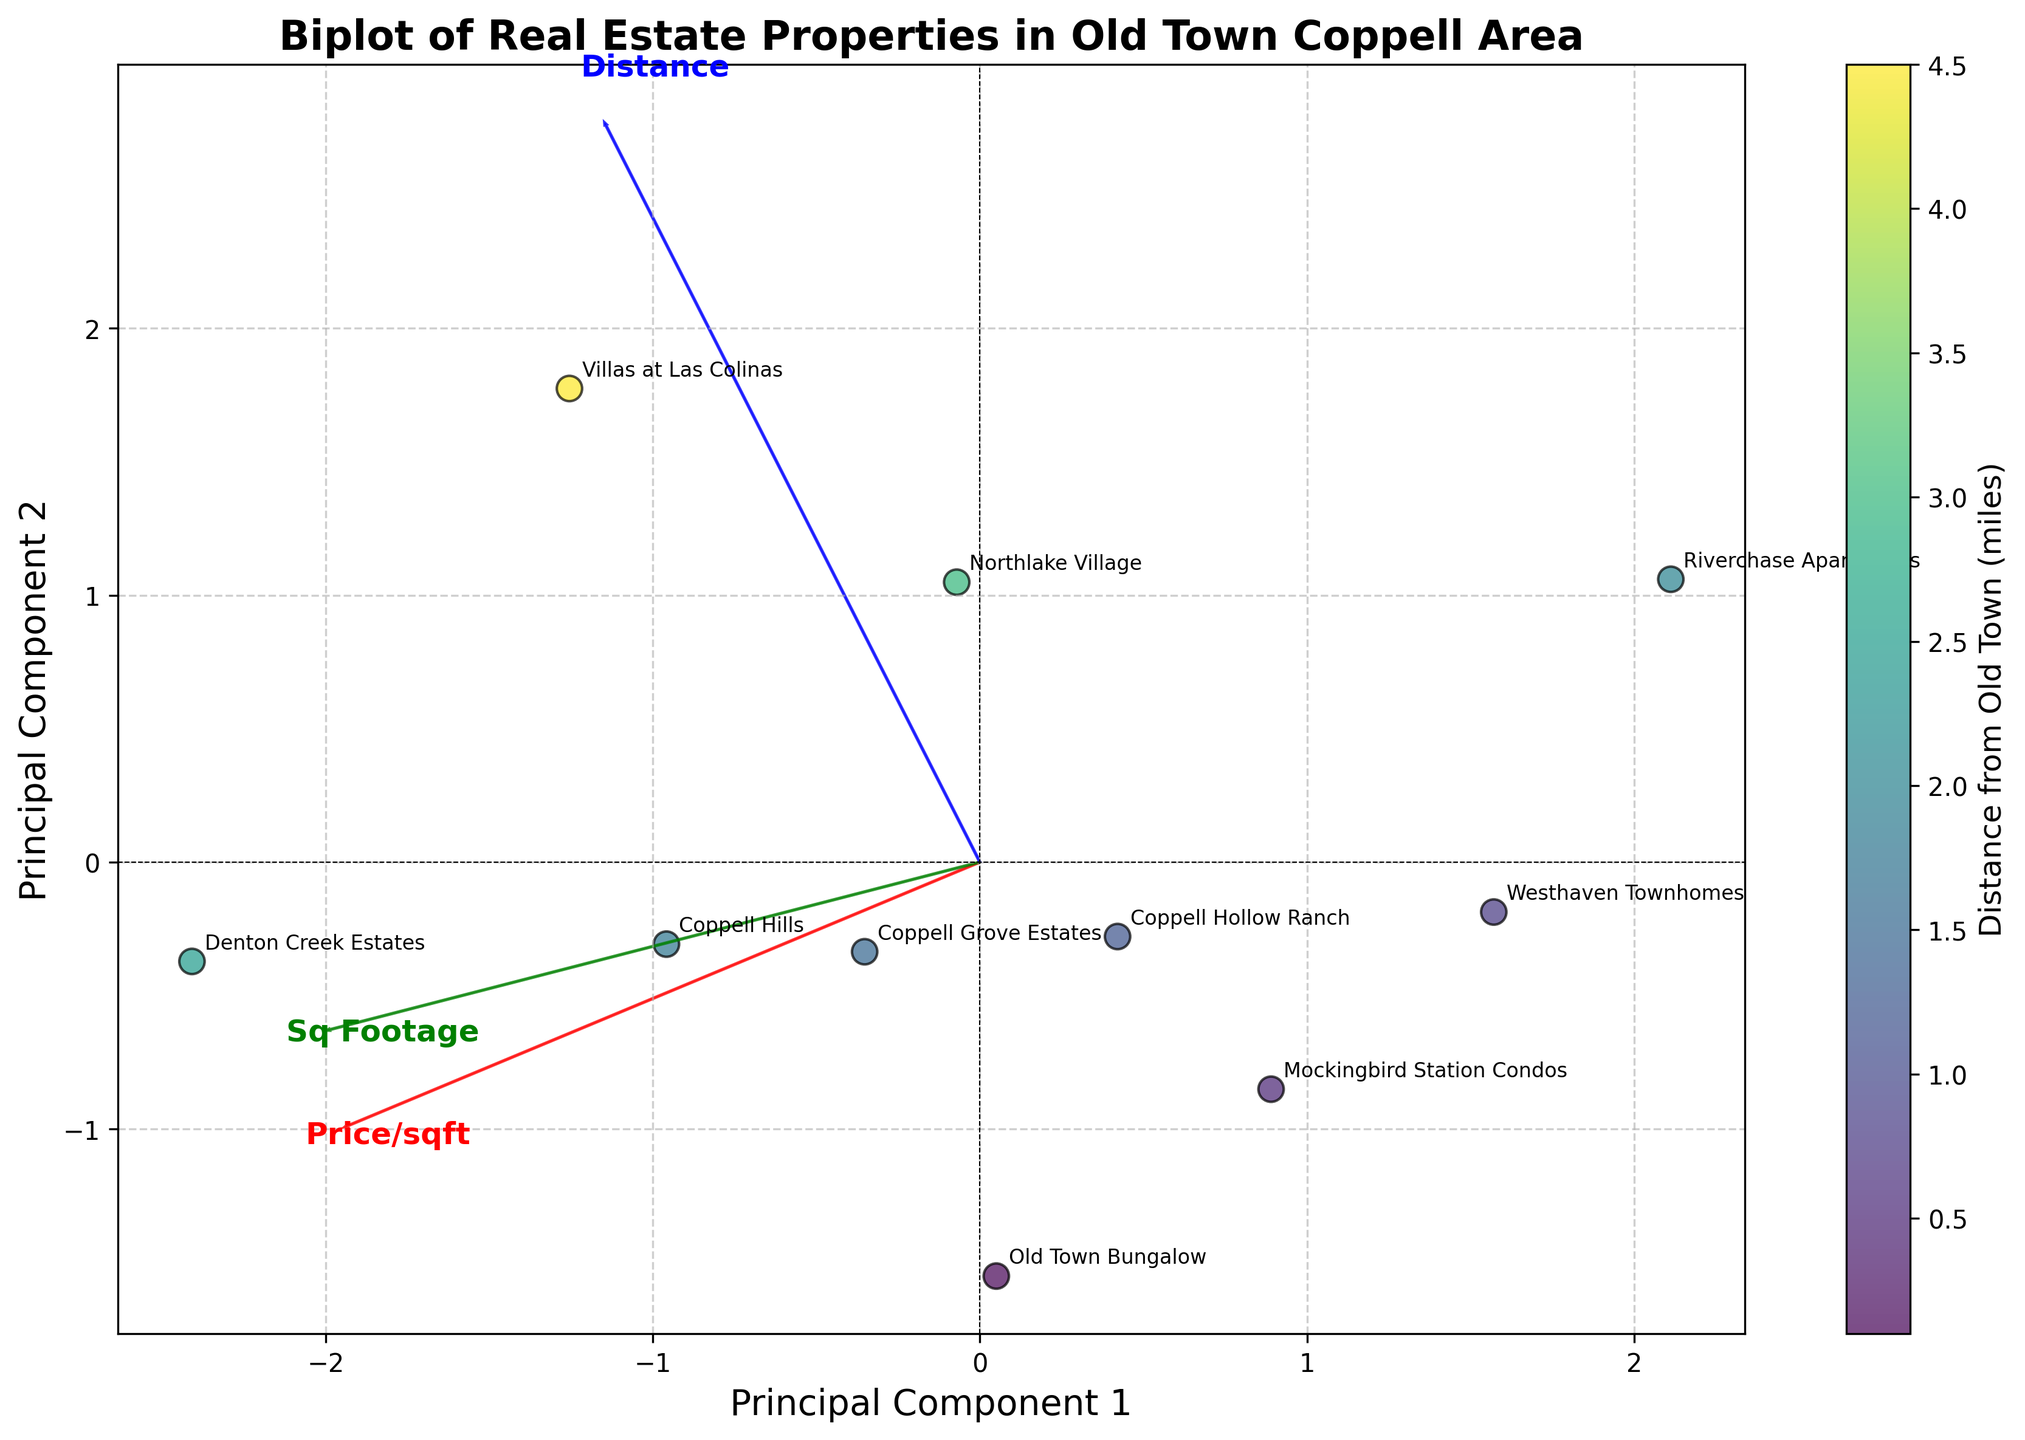What's the title of the plot? The title is written at the top of the plot. It says "Biplot of Real Estate Properties in Old Town Coppell Area".
Answer: Biplot of Real Estate Properties in Old Town Coppell Area How many data points are shown in the plot? Each property corresponds to one data point, and there are labels for each. If you count them, you'll find there are 10 points.
Answer: 10 What color represents the distance from Old Town Coppell? The color of the data points corresponds to the distance from Old Town Coppell, with a color gradient indicated by the color bar on the right side of the plot.
Answer: Viridis (multi-color gradient) Which property is farthest from Old Town Coppell? The distance from Old Town Coppell is represented by the color of the data points and noted on the plot. The farthest property should have the color furthest to the right on the color bar.
Answer: Villas at Las Colinas What do the arrows in the plot represent? The arrows in a biplot typically represent the direction and magnitude of the original features in the data, which are listed as 'Price per sqft', 'Sq Footage', and 'Distance'.
Answer: Original features Which property has the highest price per square foot? The position of the data points and their description will help in identifying the property with the highest price per square foot. The data point farthest in the direction of the 'Price/sqft' arrow has the highest value.
Answer: Denton Creek Estates How are properties from Old Town Coppell clustered compared to properties farther away? By observing the positions on the biplot relative to the distance arrow, properties in Old Town Coppell should cluster closer together, while those farther away are more spread out.
Answer: Clustered closer Which two properties have almost the same price per square foot but different square footage? By comparing the positions of data points along the 'Price/sqft' arrow, you can identify two properties close together on this dimension but separated along the 'Sq Footage' arrow.
Answer: Coppell Hills and Coppell Grove Estates What is the primary feature explaining the most variance in property characteristics? Principal Component 1 usually explains the most variance. The feature with the longest arrow in this component's direction explains the most variance.
Answer: Sq Footage How does the feature 'Distance from Old Town' contribute to the variance in the data? By analyzing the orientation and length of the 'Distance' arrow in relation to principal components, you can infer its contribution. It is along PC1, suggesting significant variance explanation.
Answer: Significant 